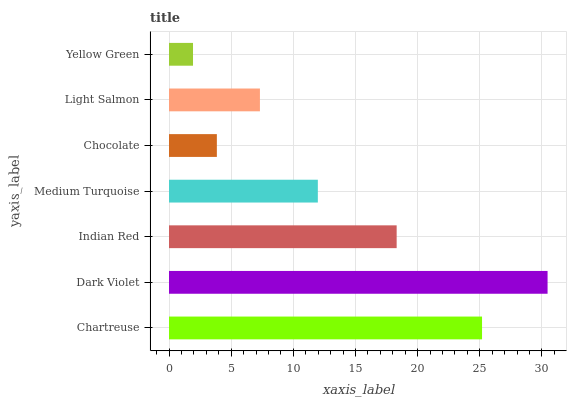Is Yellow Green the minimum?
Answer yes or no. Yes. Is Dark Violet the maximum?
Answer yes or no. Yes. Is Indian Red the minimum?
Answer yes or no. No. Is Indian Red the maximum?
Answer yes or no. No. Is Dark Violet greater than Indian Red?
Answer yes or no. Yes. Is Indian Red less than Dark Violet?
Answer yes or no. Yes. Is Indian Red greater than Dark Violet?
Answer yes or no. No. Is Dark Violet less than Indian Red?
Answer yes or no. No. Is Medium Turquoise the high median?
Answer yes or no. Yes. Is Medium Turquoise the low median?
Answer yes or no. Yes. Is Indian Red the high median?
Answer yes or no. No. Is Chartreuse the low median?
Answer yes or no. No. 